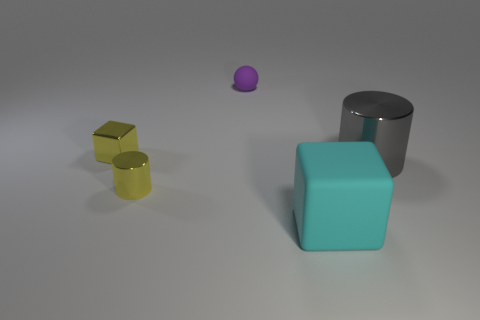Add 3 cylinders. How many objects exist? 8 Subtract 1 cubes. How many cubes are left? 1 Subtract all cubes. How many objects are left? 3 Subtract all brown cubes. Subtract all gray spheres. How many cubes are left? 2 Add 5 big cyan rubber objects. How many big cyan rubber objects are left? 6 Add 5 big red matte cubes. How many big red matte cubes exist? 5 Subtract 0 green balls. How many objects are left? 5 Subtract all blue cylinders. How many yellow balls are left? 0 Subtract all large things. Subtract all brown metallic balls. How many objects are left? 3 